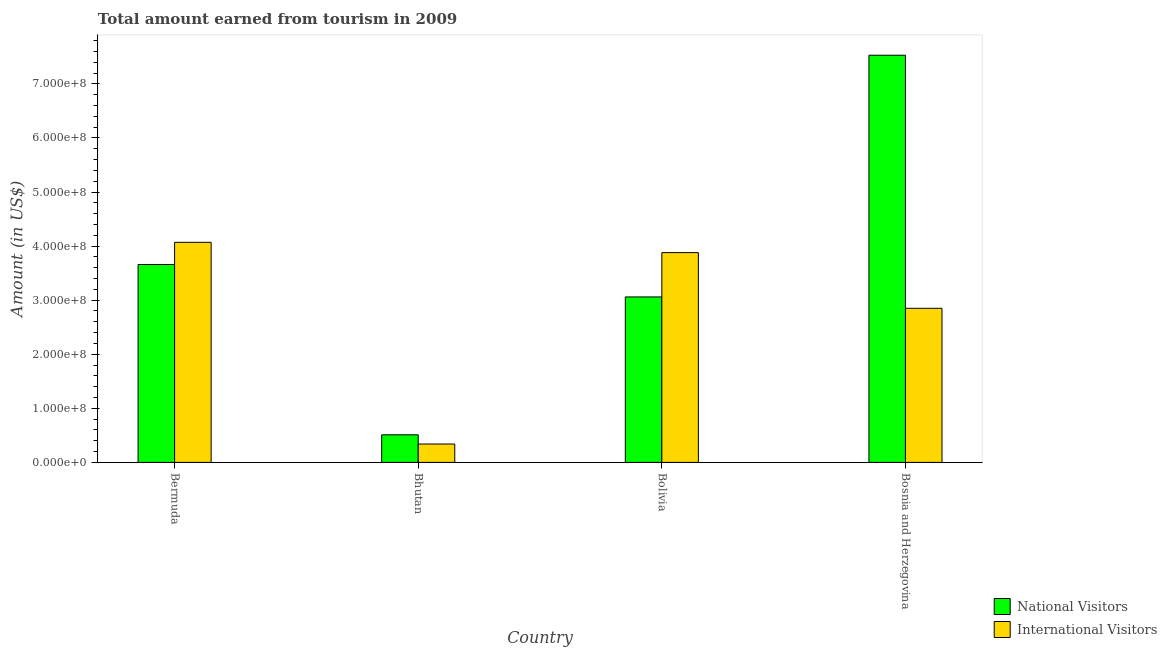How many different coloured bars are there?
Your answer should be very brief. 2. Are the number of bars per tick equal to the number of legend labels?
Make the answer very short. Yes. How many bars are there on the 2nd tick from the right?
Make the answer very short. 2. What is the label of the 1st group of bars from the left?
Offer a very short reply. Bermuda. In how many cases, is the number of bars for a given country not equal to the number of legend labels?
Your answer should be compact. 0. What is the amount earned from national visitors in Bermuda?
Your response must be concise. 3.66e+08. Across all countries, what is the maximum amount earned from national visitors?
Keep it short and to the point. 7.53e+08. Across all countries, what is the minimum amount earned from international visitors?
Provide a short and direct response. 3.40e+07. In which country was the amount earned from national visitors maximum?
Your response must be concise. Bosnia and Herzegovina. In which country was the amount earned from national visitors minimum?
Provide a short and direct response. Bhutan. What is the total amount earned from national visitors in the graph?
Give a very brief answer. 1.48e+09. What is the difference between the amount earned from international visitors in Bermuda and that in Bolivia?
Provide a succinct answer. 1.90e+07. What is the difference between the amount earned from international visitors in Bermuda and the amount earned from national visitors in Bosnia and Herzegovina?
Your response must be concise. -3.46e+08. What is the average amount earned from international visitors per country?
Keep it short and to the point. 2.78e+08. What is the difference between the amount earned from national visitors and amount earned from international visitors in Bolivia?
Offer a very short reply. -8.20e+07. In how many countries, is the amount earned from international visitors greater than 480000000 US$?
Offer a terse response. 0. What is the ratio of the amount earned from international visitors in Bhutan to that in Bolivia?
Give a very brief answer. 0.09. Is the amount earned from national visitors in Bhutan less than that in Bosnia and Herzegovina?
Your answer should be very brief. Yes. What is the difference between the highest and the second highest amount earned from national visitors?
Offer a terse response. 3.87e+08. What is the difference between the highest and the lowest amount earned from national visitors?
Provide a succinct answer. 7.02e+08. In how many countries, is the amount earned from international visitors greater than the average amount earned from international visitors taken over all countries?
Provide a succinct answer. 3. What does the 2nd bar from the left in Bhutan represents?
Your answer should be compact. International Visitors. What does the 1st bar from the right in Bolivia represents?
Make the answer very short. International Visitors. How many countries are there in the graph?
Keep it short and to the point. 4. What is the difference between two consecutive major ticks on the Y-axis?
Your response must be concise. 1.00e+08. Does the graph contain grids?
Provide a succinct answer. No. How many legend labels are there?
Make the answer very short. 2. What is the title of the graph?
Your answer should be very brief. Total amount earned from tourism in 2009. Does "Highest 20% of population" appear as one of the legend labels in the graph?
Give a very brief answer. No. What is the Amount (in US$) of National Visitors in Bermuda?
Provide a short and direct response. 3.66e+08. What is the Amount (in US$) in International Visitors in Bermuda?
Make the answer very short. 4.07e+08. What is the Amount (in US$) in National Visitors in Bhutan?
Make the answer very short. 5.10e+07. What is the Amount (in US$) in International Visitors in Bhutan?
Keep it short and to the point. 3.40e+07. What is the Amount (in US$) in National Visitors in Bolivia?
Give a very brief answer. 3.06e+08. What is the Amount (in US$) in International Visitors in Bolivia?
Make the answer very short. 3.88e+08. What is the Amount (in US$) of National Visitors in Bosnia and Herzegovina?
Keep it short and to the point. 7.53e+08. What is the Amount (in US$) in International Visitors in Bosnia and Herzegovina?
Ensure brevity in your answer.  2.85e+08. Across all countries, what is the maximum Amount (in US$) in National Visitors?
Your response must be concise. 7.53e+08. Across all countries, what is the maximum Amount (in US$) of International Visitors?
Give a very brief answer. 4.07e+08. Across all countries, what is the minimum Amount (in US$) of National Visitors?
Provide a short and direct response. 5.10e+07. Across all countries, what is the minimum Amount (in US$) of International Visitors?
Your answer should be very brief. 3.40e+07. What is the total Amount (in US$) in National Visitors in the graph?
Offer a very short reply. 1.48e+09. What is the total Amount (in US$) of International Visitors in the graph?
Your answer should be compact. 1.11e+09. What is the difference between the Amount (in US$) in National Visitors in Bermuda and that in Bhutan?
Your response must be concise. 3.15e+08. What is the difference between the Amount (in US$) of International Visitors in Bermuda and that in Bhutan?
Provide a succinct answer. 3.73e+08. What is the difference between the Amount (in US$) of National Visitors in Bermuda and that in Bolivia?
Offer a terse response. 6.00e+07. What is the difference between the Amount (in US$) in International Visitors in Bermuda and that in Bolivia?
Your answer should be compact. 1.90e+07. What is the difference between the Amount (in US$) of National Visitors in Bermuda and that in Bosnia and Herzegovina?
Ensure brevity in your answer.  -3.87e+08. What is the difference between the Amount (in US$) of International Visitors in Bermuda and that in Bosnia and Herzegovina?
Your response must be concise. 1.22e+08. What is the difference between the Amount (in US$) in National Visitors in Bhutan and that in Bolivia?
Offer a terse response. -2.55e+08. What is the difference between the Amount (in US$) of International Visitors in Bhutan and that in Bolivia?
Offer a terse response. -3.54e+08. What is the difference between the Amount (in US$) of National Visitors in Bhutan and that in Bosnia and Herzegovina?
Ensure brevity in your answer.  -7.02e+08. What is the difference between the Amount (in US$) in International Visitors in Bhutan and that in Bosnia and Herzegovina?
Your answer should be very brief. -2.51e+08. What is the difference between the Amount (in US$) in National Visitors in Bolivia and that in Bosnia and Herzegovina?
Your answer should be compact. -4.47e+08. What is the difference between the Amount (in US$) in International Visitors in Bolivia and that in Bosnia and Herzegovina?
Offer a terse response. 1.03e+08. What is the difference between the Amount (in US$) in National Visitors in Bermuda and the Amount (in US$) in International Visitors in Bhutan?
Give a very brief answer. 3.32e+08. What is the difference between the Amount (in US$) in National Visitors in Bermuda and the Amount (in US$) in International Visitors in Bolivia?
Offer a terse response. -2.20e+07. What is the difference between the Amount (in US$) of National Visitors in Bermuda and the Amount (in US$) of International Visitors in Bosnia and Herzegovina?
Offer a very short reply. 8.10e+07. What is the difference between the Amount (in US$) in National Visitors in Bhutan and the Amount (in US$) in International Visitors in Bolivia?
Your answer should be compact. -3.37e+08. What is the difference between the Amount (in US$) in National Visitors in Bhutan and the Amount (in US$) in International Visitors in Bosnia and Herzegovina?
Make the answer very short. -2.34e+08. What is the difference between the Amount (in US$) in National Visitors in Bolivia and the Amount (in US$) in International Visitors in Bosnia and Herzegovina?
Offer a terse response. 2.10e+07. What is the average Amount (in US$) of National Visitors per country?
Provide a short and direct response. 3.69e+08. What is the average Amount (in US$) in International Visitors per country?
Your answer should be compact. 2.78e+08. What is the difference between the Amount (in US$) of National Visitors and Amount (in US$) of International Visitors in Bermuda?
Your answer should be very brief. -4.10e+07. What is the difference between the Amount (in US$) in National Visitors and Amount (in US$) in International Visitors in Bhutan?
Offer a terse response. 1.70e+07. What is the difference between the Amount (in US$) in National Visitors and Amount (in US$) in International Visitors in Bolivia?
Your response must be concise. -8.20e+07. What is the difference between the Amount (in US$) of National Visitors and Amount (in US$) of International Visitors in Bosnia and Herzegovina?
Keep it short and to the point. 4.68e+08. What is the ratio of the Amount (in US$) in National Visitors in Bermuda to that in Bhutan?
Provide a short and direct response. 7.18. What is the ratio of the Amount (in US$) in International Visitors in Bermuda to that in Bhutan?
Provide a short and direct response. 11.97. What is the ratio of the Amount (in US$) in National Visitors in Bermuda to that in Bolivia?
Ensure brevity in your answer.  1.2. What is the ratio of the Amount (in US$) in International Visitors in Bermuda to that in Bolivia?
Your response must be concise. 1.05. What is the ratio of the Amount (in US$) of National Visitors in Bermuda to that in Bosnia and Herzegovina?
Make the answer very short. 0.49. What is the ratio of the Amount (in US$) in International Visitors in Bermuda to that in Bosnia and Herzegovina?
Ensure brevity in your answer.  1.43. What is the ratio of the Amount (in US$) in National Visitors in Bhutan to that in Bolivia?
Offer a terse response. 0.17. What is the ratio of the Amount (in US$) of International Visitors in Bhutan to that in Bolivia?
Ensure brevity in your answer.  0.09. What is the ratio of the Amount (in US$) of National Visitors in Bhutan to that in Bosnia and Herzegovina?
Offer a terse response. 0.07. What is the ratio of the Amount (in US$) of International Visitors in Bhutan to that in Bosnia and Herzegovina?
Your response must be concise. 0.12. What is the ratio of the Amount (in US$) of National Visitors in Bolivia to that in Bosnia and Herzegovina?
Ensure brevity in your answer.  0.41. What is the ratio of the Amount (in US$) of International Visitors in Bolivia to that in Bosnia and Herzegovina?
Your answer should be compact. 1.36. What is the difference between the highest and the second highest Amount (in US$) of National Visitors?
Keep it short and to the point. 3.87e+08. What is the difference between the highest and the second highest Amount (in US$) in International Visitors?
Provide a succinct answer. 1.90e+07. What is the difference between the highest and the lowest Amount (in US$) of National Visitors?
Keep it short and to the point. 7.02e+08. What is the difference between the highest and the lowest Amount (in US$) in International Visitors?
Offer a terse response. 3.73e+08. 